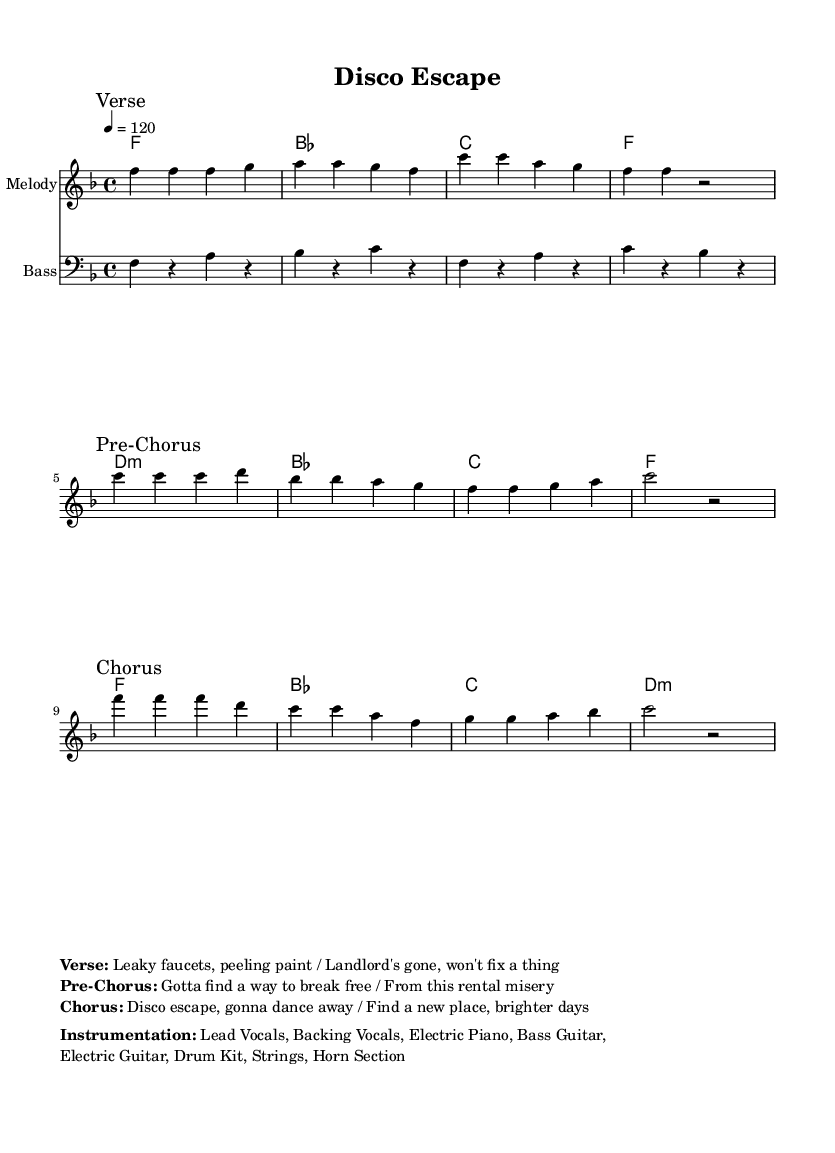What is the key signature of this music? The key signature is F major, which has one flat (B flat). The key is indicated at the beginning of the sheet music.
Answer: F major What is the time signature of this music? The time signature is 4/4, which means there are four beats in each measure. It is indicated right after the key signature.
Answer: 4/4 What is the tempo marking for this piece? The tempo marking is 120 beats per minute, indicated in quarter note value. It reflects a fast and upbeat disco feel.
Answer: 120 How many sections does the song have? The song has three main sections which are labeled as "Verse," "Pre-Chorus," and "Chorus." Each section is clearly marked in the melody part.
Answer: Three Which instrument is playing the bass part? The bass part is labeled under the staff with 'Bass' notation, indicating it is played by the bass guitar or similar low-end instrument.
Answer: Bass What is the title of this music piece? The title "Disco Escape" is prominently displayed at the top of the sheet music, indicating the theme of the song.
Answer: Disco Escape What mood does this piece convey? The overall mood conveyed by the combination of upbeat tempo and lyrics about escaping trouble suggests an uplifting and energetic feeling typical of disco music.
Answer: Uplifting 